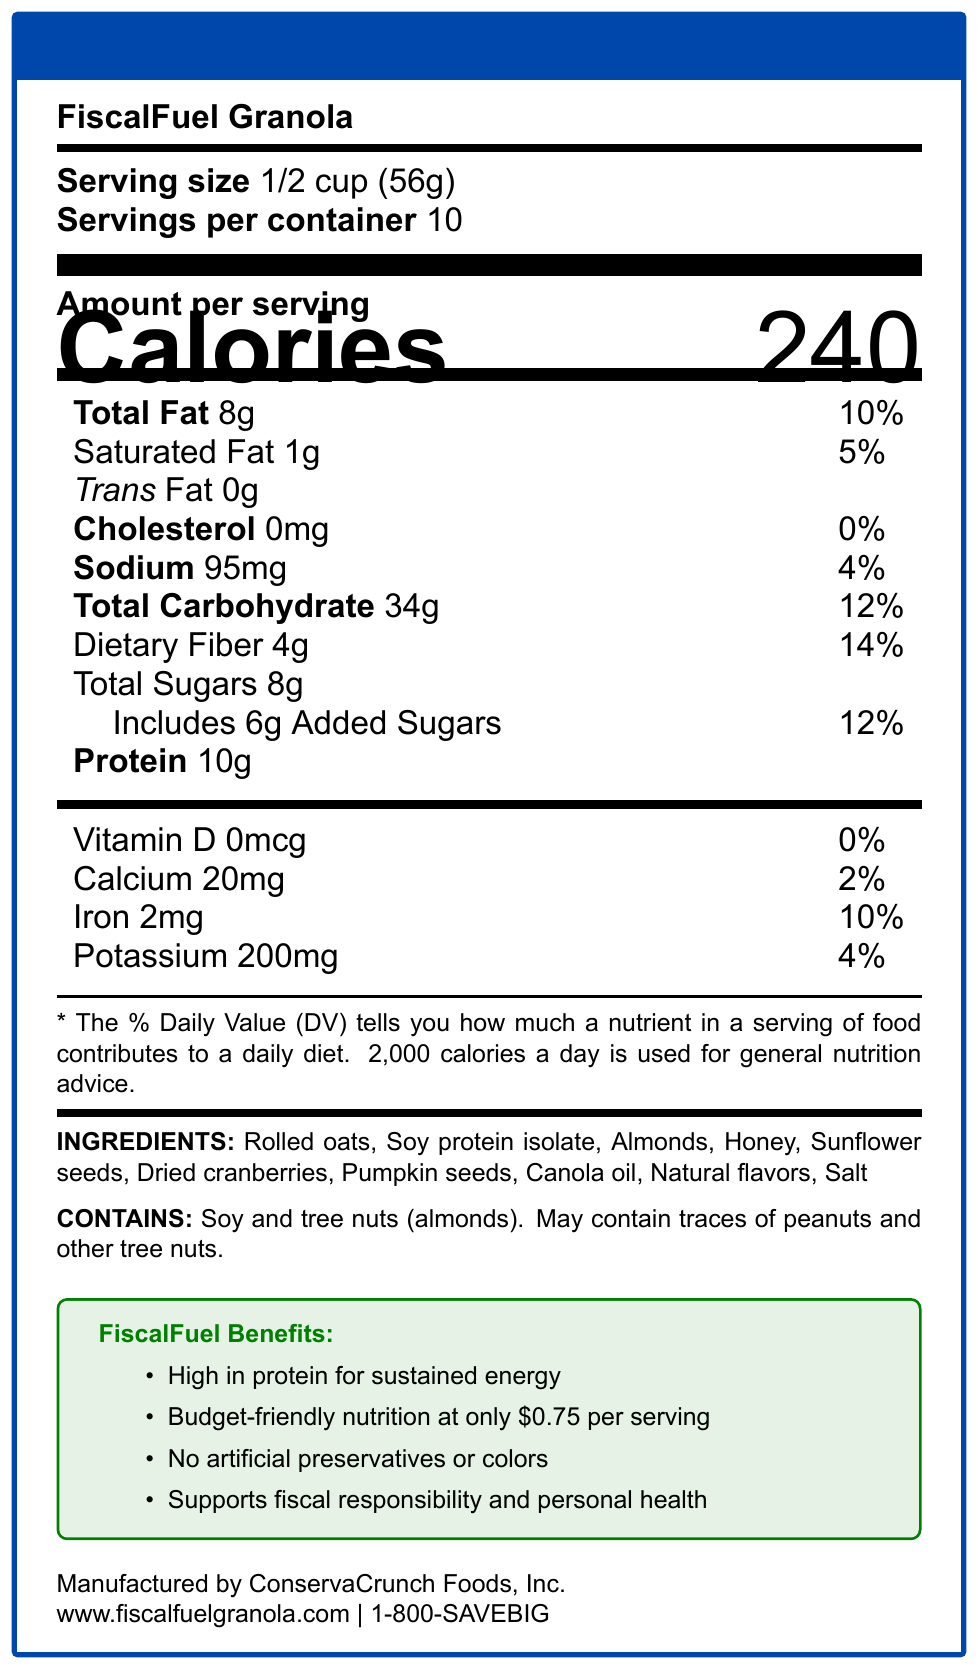what is the serving size? The serving size is explicitly mentioned in the document under the header "Serving size."
Answer: 1/2 cup (56g) how many calories are in one serving? The document lists "Calories 240" in the section about the amount per serving.
Answer: 240 how much protein is in one serving? The amount of protein per serving is listed as "Protein 10g" in the document.
Answer: 10g what is the shelf life of FiscalFuel Granola? The shelf life is mentioned as "12 months when stored in a cool, dry place" in the latter part of the document.
Answer: 12 months when stored in a cool, dry place what are the main ingredients in FiscalFuel Granola? The ingredients are listed in the "INGREDIENTS" section of the document.
Answer: Rolled oats, soy protein isolate, almonds, honey, sunflower seeds, dried cranberries, pumpkin seeds, canola oil, natural flavors, salt how much does one serving cost? The cost per serving is detailed at $0.75 in the section talking about the benefits of the product.
Answer: $0.75 which of the following is not an ingredient in FiscalFuel Granola? A. Rolled oats B. Soy protein isolate C. Dried cranberries D. Brown sugar The ingredients listed in the document do not include brown sugar.
Answer: D. Brown sugar what percentage of daily value for iron does one serving provide? A. 2% B. 4% C. 10% D. 14% The document states that one serving provides 10% of the daily value for iron.
Answer: C. 10% is FiscalFuel Granola high in protein? The granola is marketed as "High in protein for sustained energy," and it contains 10g of protein per serving.
Answer: Yes should I be concerned with any allergens in FiscalFuel Granola if I have nut allergies? The allergen information states that the product contains soy and tree nuts (almonds) and may contain traces of peanuts and other tree nuts.
Answer: Yes how many servings are in one container? The document specifies "Servings per container 10."
Answer: 10 describe the main idea of this document. The document highlights the product's nutritional merits, allergen info, cost, shelf life, and packaging details to appeal to calorie-conscious, budget-aware consumers.
Answer: The document provides detailed nutrition information for FiscalFuel Granola, a high-protein, budget-friendly granola blend that promotes health and fiscal responsibility. who is the manufacturer of FiscalFuel Granola? The manufacturer is stated as ConservaCrunch Foods, Inc., at the bottom of the document.
Answer: ConservaCrunch Foods, Inc. what is the contact information for customer service? The customer service contact is listed as 1-800-SAVEBIG at the bottom of the document.
Answer: 1-800-SAVEBIG what is the website for more information on FiscalFuel Granola? The website is listed as www.fiscalfuelgranola.com at the bottom of the document.
Answer: www.fiscalfuelgranola.com what vitamins and minerals can be found in FiscalFuel Granola? The vitamins and minerals listed are Vitamin D (0mcg), calcium (20mg), iron (2mg), and potassium (200mg).
Answer: Vitamin D, calcium, iron, potassium how many grams of saturated fat does one serving of FiscalFuel Granola contain? The saturated fat content per serving is listed as 1g.
Answer: 1g how many grams of added sugars are there in one serving? The document states that there are 6g of added sugars per serving.
Answer: 6g what are the main benefits promoted for FiscalFuel Granola? The main benefits are listed in the "FiscalFuel Benefits" section of the document.
Answer: High in protein, budget-friendly nutrition, no artificial preservatives or colors, supports fiscal responsibility and personal health what is the exact amount of potassium per serving? The potassium content is listed as 200mg per serving in the nutritional information tabular section.
Answer: 200mg what is the total fat content as a percentage of daily value? The total fat content per serving is listed as 10% of the daily value.
Answer: 10% does the packaging include any recyclable materials? The packaging includes a recyclable paperboard box with an inner plastic bag.
Answer: Yes how does FiscalFuel Granola support fiscal responsibility? The product is promoted as budget-friendly at $0.75 per serving, which supports fiscal responsibility.
Answer: By offering budget-friendly nutrition at only $0.75 per serving how has the product manufacturing been described? The document does not provide specific details about the manufacturing process, only the manufacturer’s name and contact info.
Answer: Not enough information what amount of sodium is in one serving? The sodium content per serving is listed as 95mg.
Answer: 95mg 